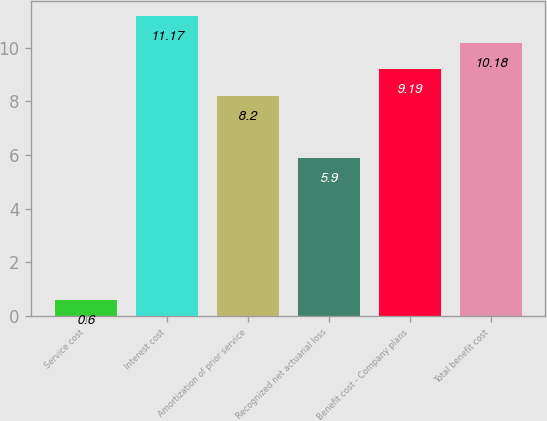Convert chart. <chart><loc_0><loc_0><loc_500><loc_500><bar_chart><fcel>Service cost<fcel>Interest cost<fcel>Amortization of prior service<fcel>Recognized net actuarial loss<fcel>Benefit cost - Company plans<fcel>Total benefit cost<nl><fcel>0.6<fcel>11.17<fcel>8.2<fcel>5.9<fcel>9.19<fcel>10.18<nl></chart> 